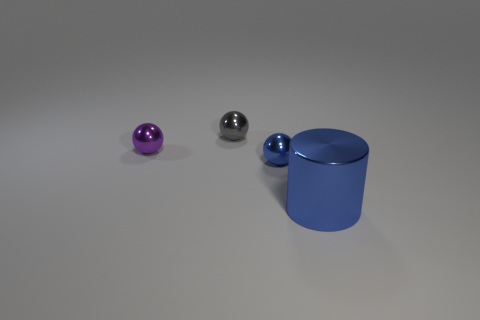There is a big metallic cylinder; does it have the same color as the metallic ball that is in front of the small purple shiny ball?
Provide a short and direct response. Yes. Is there a brown block that has the same material as the tiny purple ball?
Give a very brief answer. No. How many gray metallic things are there?
Give a very brief answer. 1. What is the blue thing that is on the right side of the blue metallic thing behind the big blue metallic cylinder made of?
Keep it short and to the point. Metal. There is a large object that is made of the same material as the gray sphere; what is its color?
Offer a very short reply. Blue. There is another thing that is the same color as the large shiny thing; what is its shape?
Provide a short and direct response. Sphere. There is a thing right of the tiny blue shiny object; does it have the same size as the blue metal object that is behind the large cylinder?
Ensure brevity in your answer.  No. What number of balls are either large blue metallic things or tiny gray objects?
Provide a short and direct response. 1. Are the blue object on the left side of the large cylinder and the large blue cylinder made of the same material?
Offer a terse response. Yes. How many other things are the same size as the gray shiny ball?
Make the answer very short. 2. 